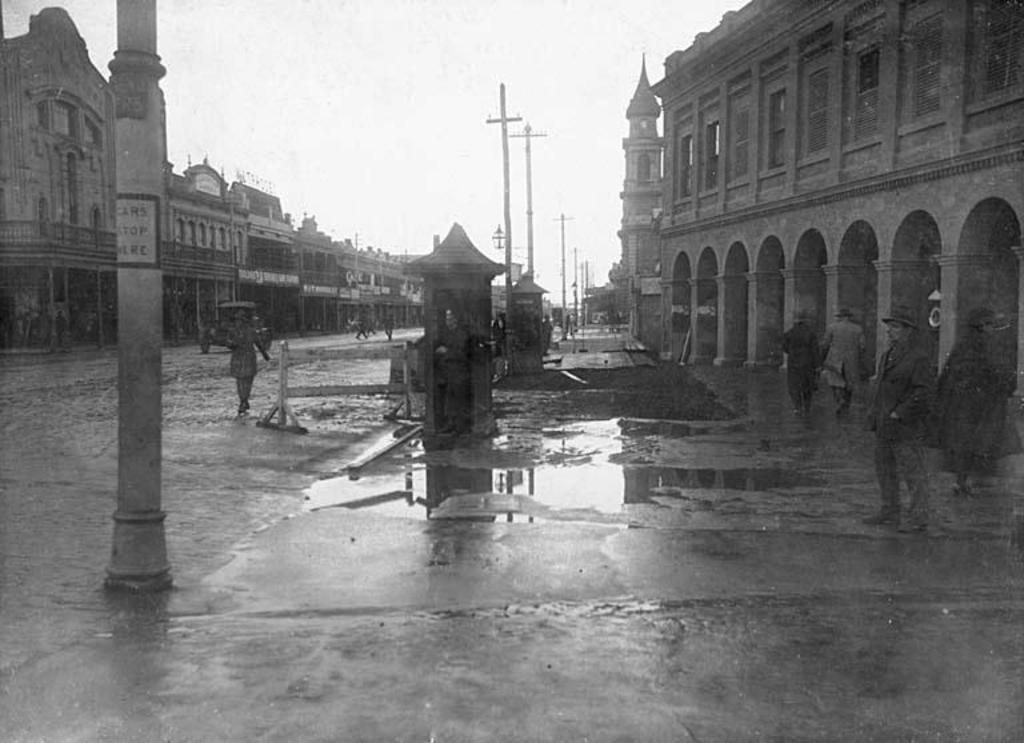Could you give a brief overview of what you see in this image? In this image, we can see a road in between buildings. There are some persons standing and wearing clothes. There are poles in the middle of the road. There is a sky at the top of the image. 